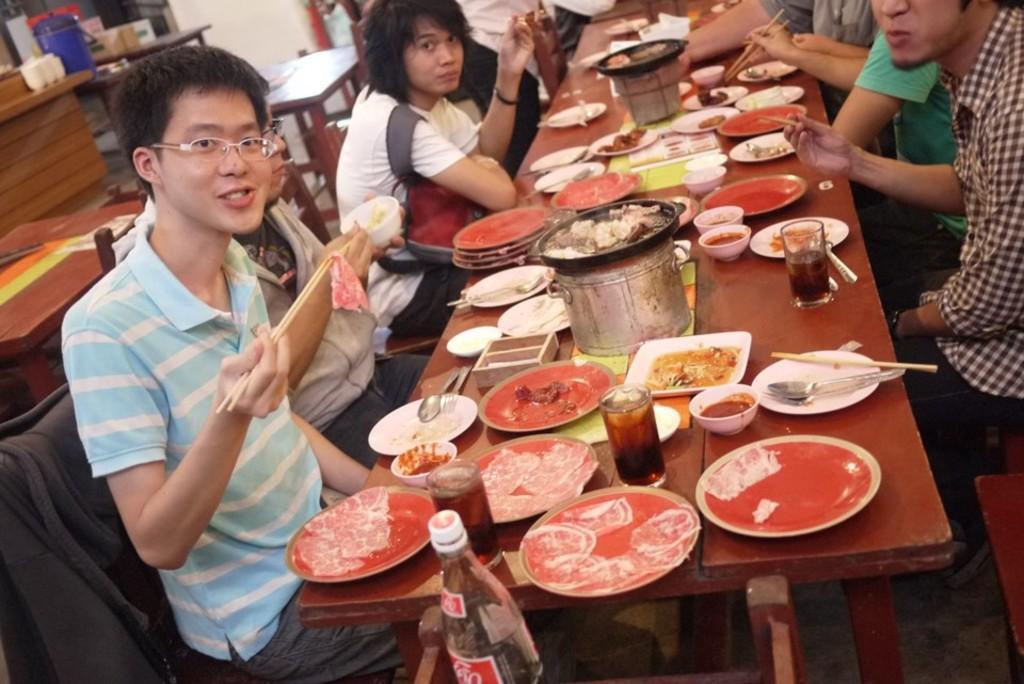Could you give a brief overview of what you see in this image? In this image there are a group of people sitting, and they are holding chopsticks and eating. And in the center there is one table, on the table there are some plates, bowls, glasses, vessels and some objects. And in the background there are some tables, cans wall and some other objects. At the bottom there is one bottle. 